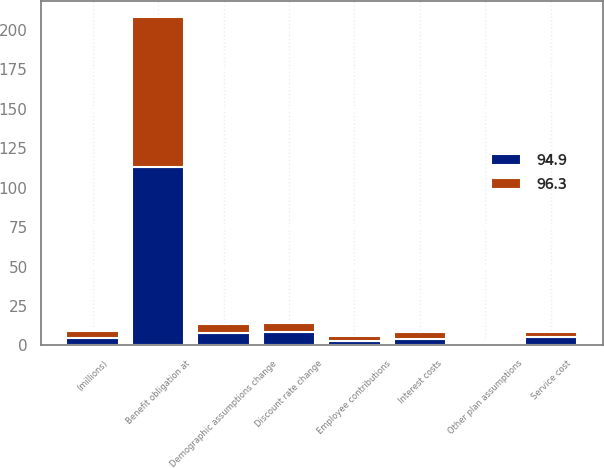Convert chart. <chart><loc_0><loc_0><loc_500><loc_500><stacked_bar_chart><ecel><fcel>(millions)<fcel>Benefit obligation at<fcel>Service cost<fcel>Interest costs<fcel>Employee contributions<fcel>Demographic assumptions change<fcel>Other plan assumptions<fcel>Discount rate change<nl><fcel>96.3<fcel>4.7<fcel>94.9<fcel>3.6<fcel>4.3<fcel>2.9<fcel>5.8<fcel>1.1<fcel>5.8<nl><fcel>94.9<fcel>4.7<fcel>112.8<fcel>5.1<fcel>4.1<fcel>2.9<fcel>8.1<fcel>1.5<fcel>8.7<nl></chart> 